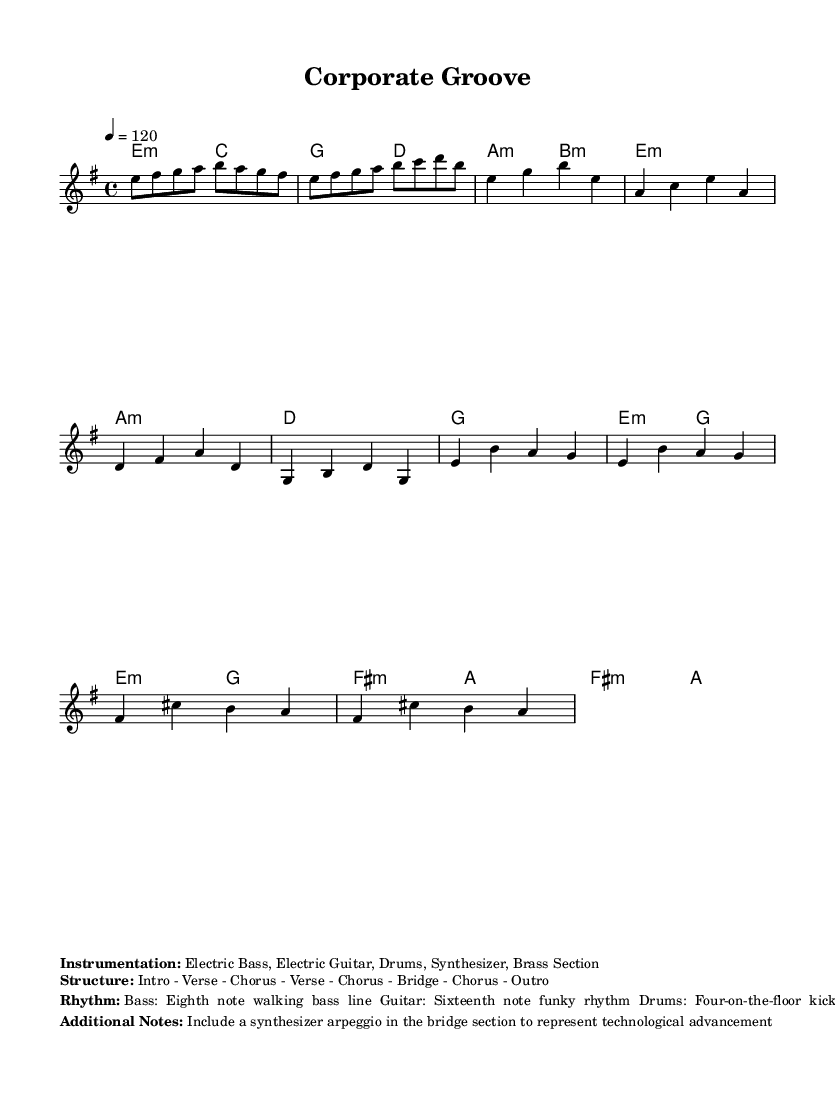What is the key signature of this music? The key signature is E minor, which is represented by one sharp (F#) in the key signature area.
Answer: E minor What is the time signature of the piece? The time signature is indicated as 4/4, meaning there are four beats in each measure and a quarter note receives one beat.
Answer: 4/4 What is the tempo indication for this piece? The tempo is set at 120 beats per minute, which is indicated by the marking at the beginning of the score.
Answer: 120 How many sections are there in the song structure? The structure is outlined clearly in the additional notes, showing that it contains eight distinct sections including verses and choruses.
Answer: Eight What instrumentation is specified for this piece? The sheet music lists the following instruments: Electric Bass, Electric Guitar, Drums, Synthesizer, Brass Section.
Answer: Electric Bass, Electric Guitar, Drums, Synthesizer, Brass Section What type of bass line is featured in this disco tune? The rhythm section indicates that the bass line is described as an eighth note walking bass line, which is typical for disco music.
Answer: Eighth note walking bass line What does the bridge section represent in the context of this tune? The additional notes describe the bridge section as featuring a synthesizer arpeggio to symbolize technological advancement, showcasing the intersection of music and tech in a competitive business landscape.
Answer: Technological advancement 